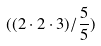Convert formula to latex. <formula><loc_0><loc_0><loc_500><loc_500>( ( 2 \cdot 2 \cdot 3 ) / \frac { 5 } { 5 } )</formula> 